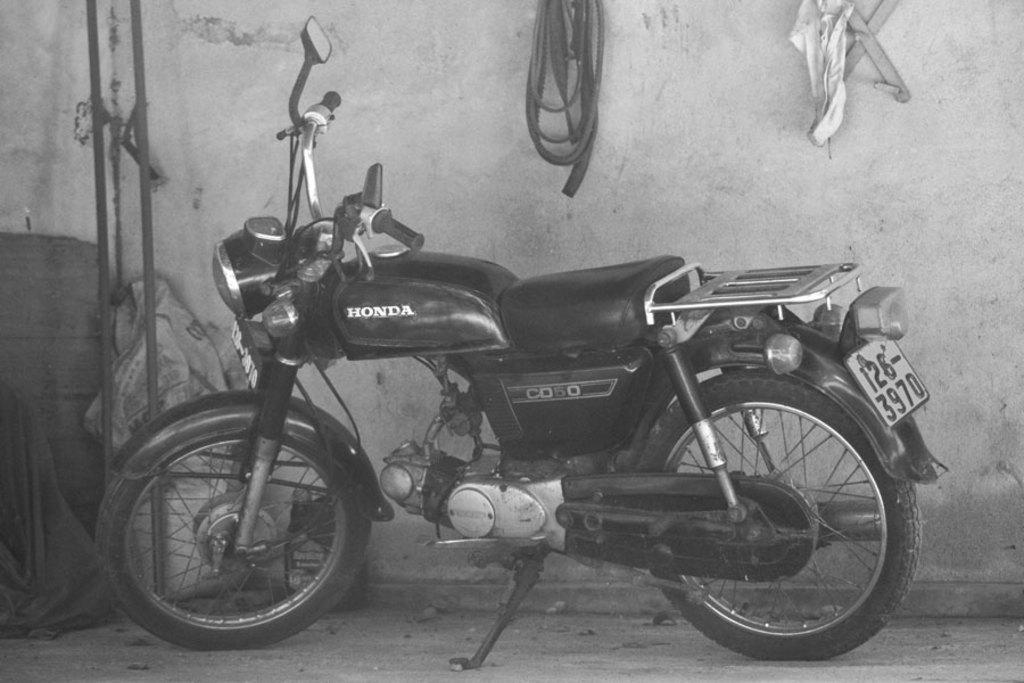Could you give a brief overview of what you see in this image? In this image I can see the black and white picture in which I can see a motorbike on the ground. In the background I can see the wall, few objects hanged to the wall, two metal rods and few other objects. 